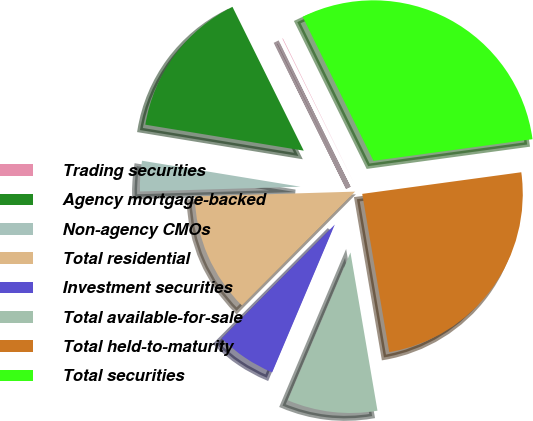Convert chart. <chart><loc_0><loc_0><loc_500><loc_500><pie_chart><fcel>Trading securities<fcel>Agency mortgage-backed<fcel>Non-agency CMOs<fcel>Total residential<fcel>Investment securities<fcel>Total available-for-sale<fcel>Total held-to-maturity<fcel>Total securities<nl><fcel>0.05%<fcel>15.09%<fcel>3.06%<fcel>12.08%<fcel>6.07%<fcel>9.07%<fcel>24.46%<fcel>30.12%<nl></chart> 